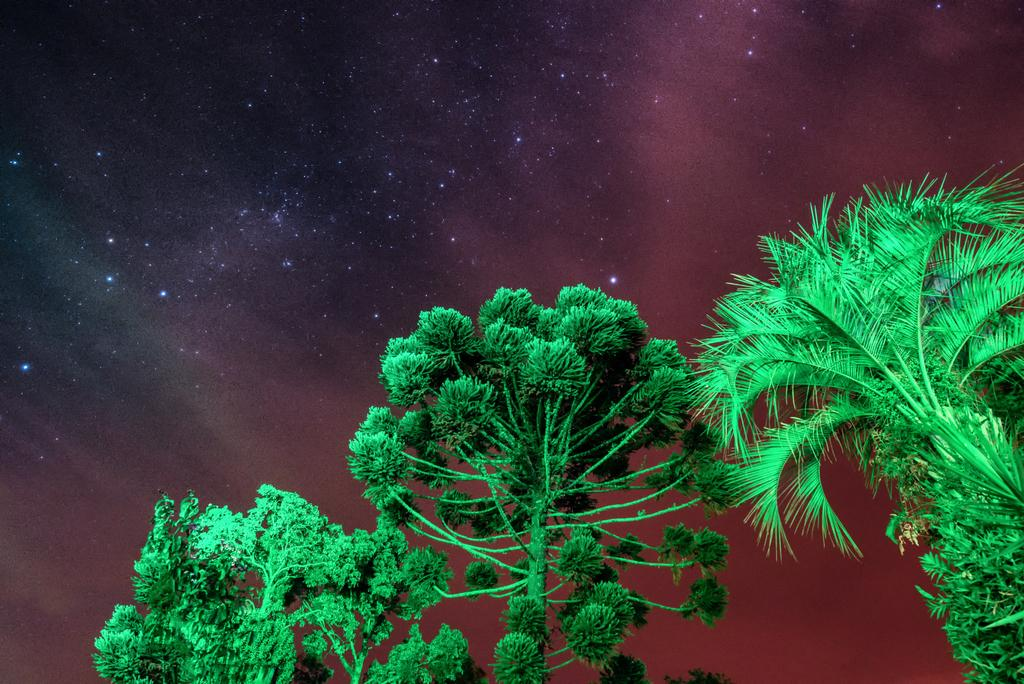What type of vegetation can be seen in the image? There are trees in the image. What can be seen in the sky in the background of the image? There are stars visible in the sky in the background of the image. Are there any nuts hanging from the trees in the image? There is no mention of nuts in the image, so we cannot determine if any are hanging from the trees. 